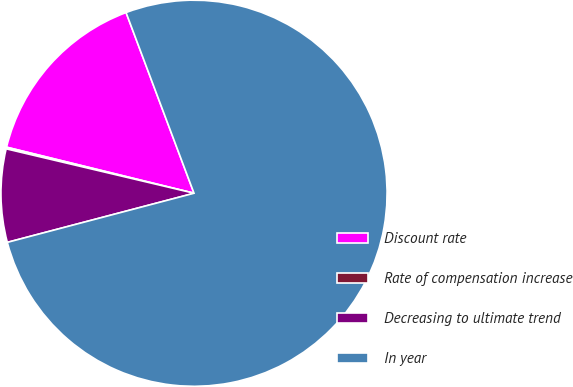Convert chart. <chart><loc_0><loc_0><loc_500><loc_500><pie_chart><fcel>Discount rate<fcel>Rate of compensation increase<fcel>Decreasing to ultimate trend<fcel>In year<nl><fcel>15.44%<fcel>0.14%<fcel>7.79%<fcel>76.63%<nl></chart> 